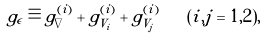Convert formula to latex. <formula><loc_0><loc_0><loc_500><loc_500>g _ { \epsilon } \equiv g _ { \nabla } ^ { ( i ) } + g _ { V _ { i } } ^ { ( i ) } + g _ { V _ { j } } ^ { ( i ) } \quad ( i , j = 1 , 2 ) ,</formula> 